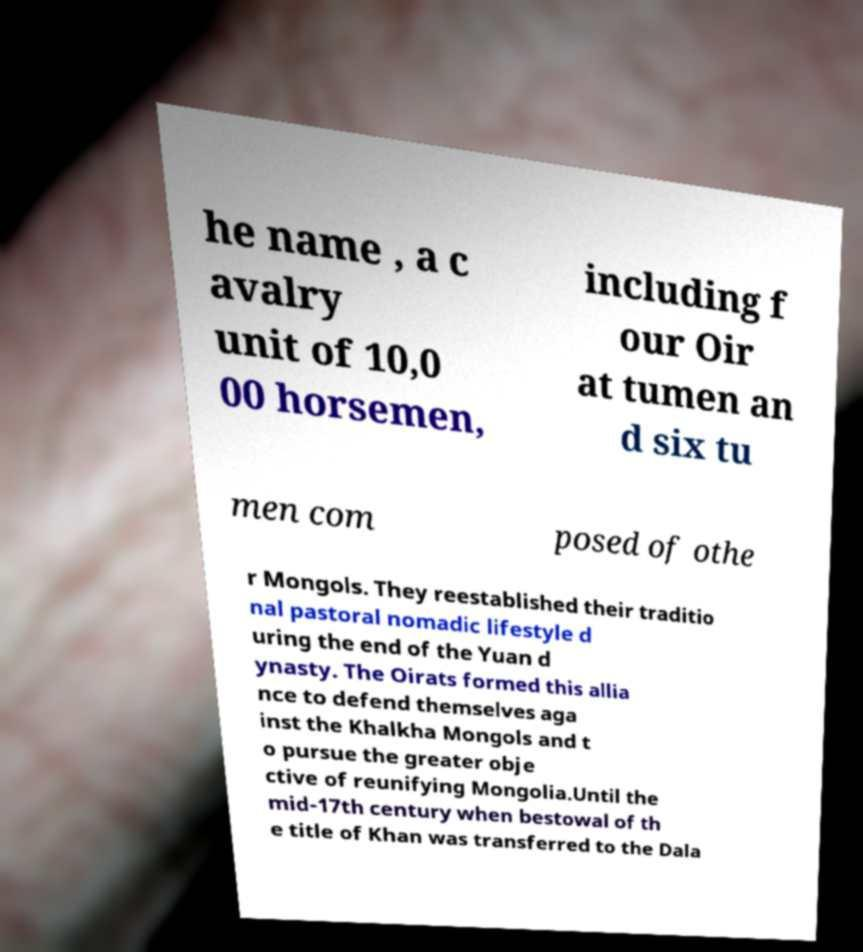Please read and relay the text visible in this image. What does it say? he name , a c avalry unit of 10,0 00 horsemen, including f our Oir at tumen an d six tu men com posed of othe r Mongols. They reestablished their traditio nal pastoral nomadic lifestyle d uring the end of the Yuan d ynasty. The Oirats formed this allia nce to defend themselves aga inst the Khalkha Mongols and t o pursue the greater obje ctive of reunifying Mongolia.Until the mid-17th century when bestowal of th e title of Khan was transferred to the Dala 